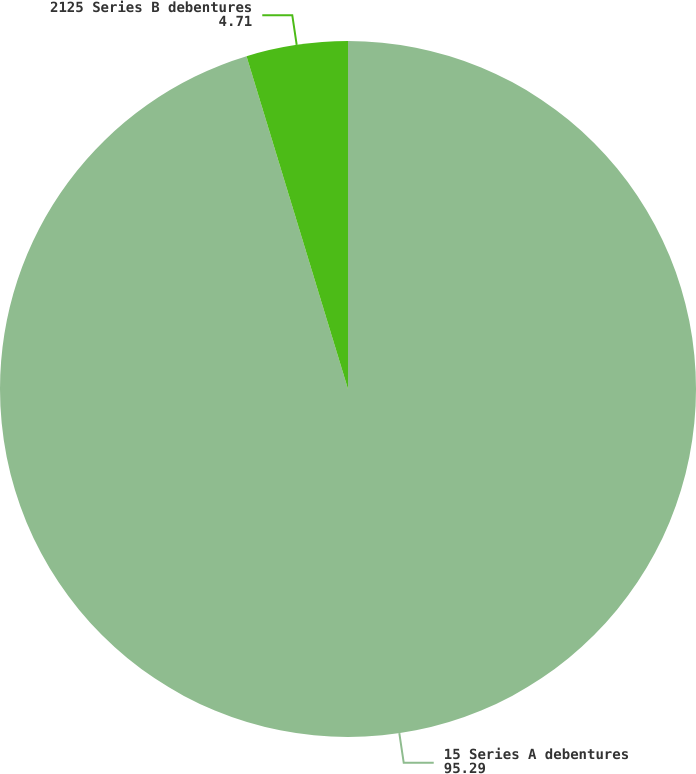Convert chart to OTSL. <chart><loc_0><loc_0><loc_500><loc_500><pie_chart><fcel>15 Series A debentures<fcel>2125 Series B debentures<nl><fcel>95.29%<fcel>4.71%<nl></chart> 